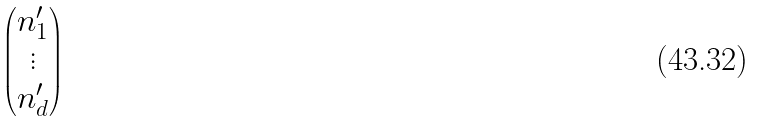<formula> <loc_0><loc_0><loc_500><loc_500>\begin{pmatrix} n _ { 1 } ^ { \prime } \\ \vdots \\ n _ { d } ^ { \prime } \end{pmatrix}</formula> 